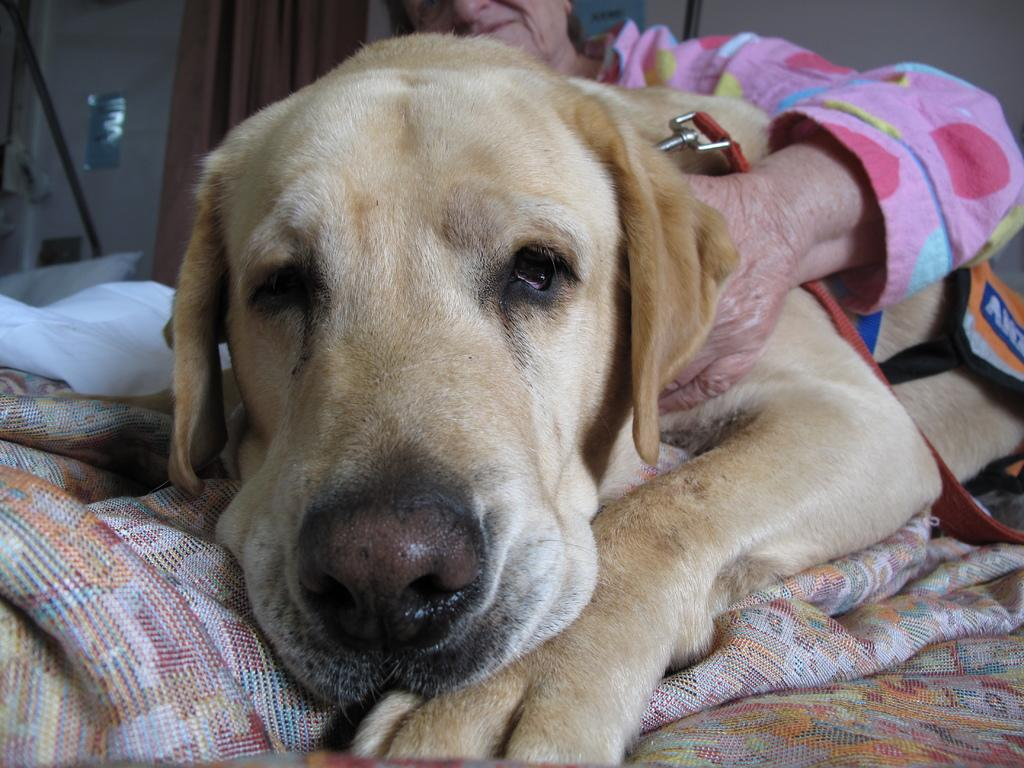Who is the main subject in the image? There is an old woman in the image. What is the old woman holding in the image? The old woman is holding a dog. What can be seen in the background of the image? There is a wall and a curtain in the background of the image. What type of bead is the old woman wearing in the image? There is no bead visible on the old woman in the image. What kind of toys can be seen in the image? There are no toys present in the image. 